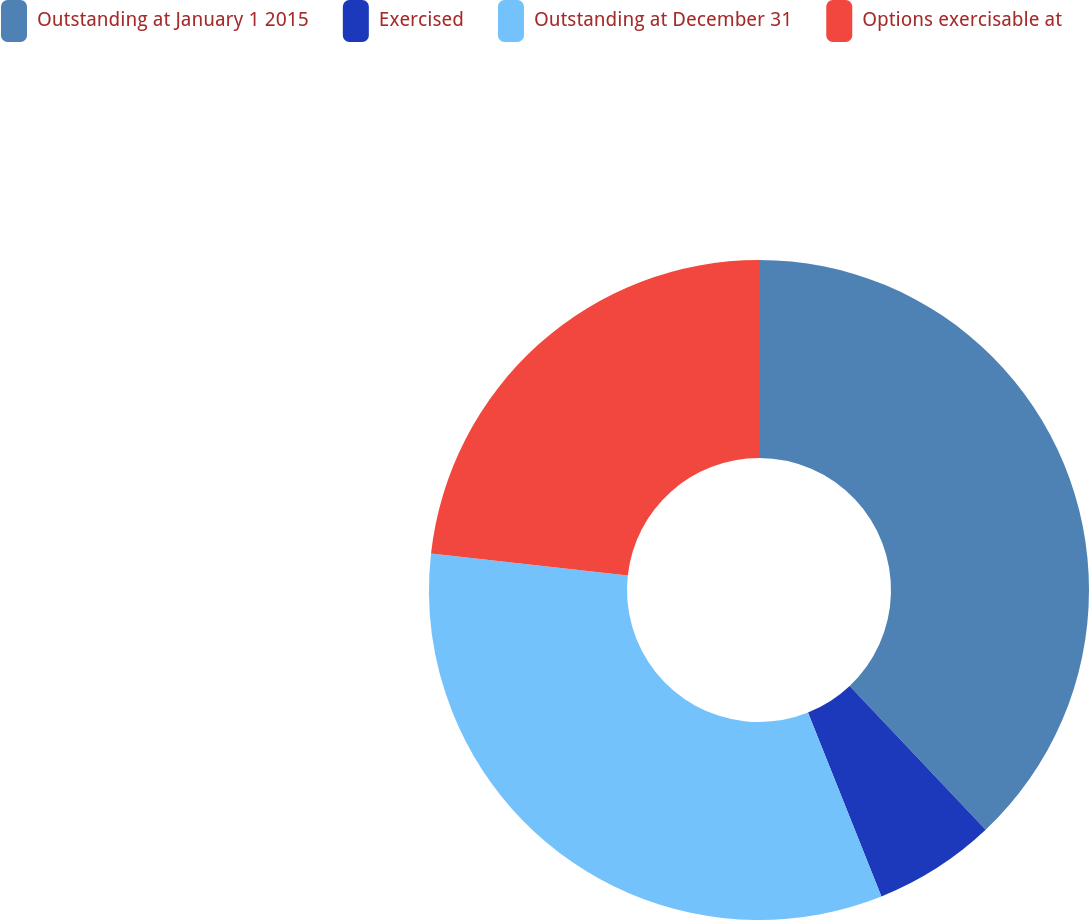Convert chart to OTSL. <chart><loc_0><loc_0><loc_500><loc_500><pie_chart><fcel>Outstanding at January 1 2015<fcel>Exercised<fcel>Outstanding at December 31<fcel>Options exercisable at<nl><fcel>37.95%<fcel>6.0%<fcel>32.81%<fcel>23.24%<nl></chart> 